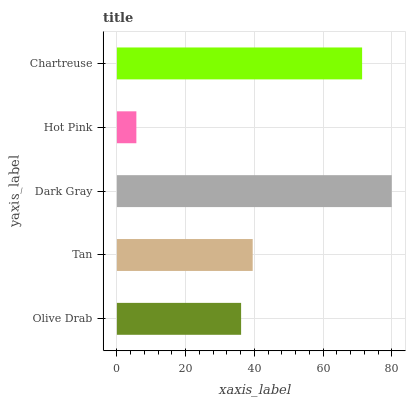Is Hot Pink the minimum?
Answer yes or no. Yes. Is Dark Gray the maximum?
Answer yes or no. Yes. Is Tan the minimum?
Answer yes or no. No. Is Tan the maximum?
Answer yes or no. No. Is Tan greater than Olive Drab?
Answer yes or no. Yes. Is Olive Drab less than Tan?
Answer yes or no. Yes. Is Olive Drab greater than Tan?
Answer yes or no. No. Is Tan less than Olive Drab?
Answer yes or no. No. Is Tan the high median?
Answer yes or no. Yes. Is Tan the low median?
Answer yes or no. Yes. Is Dark Gray the high median?
Answer yes or no. No. Is Hot Pink the low median?
Answer yes or no. No. 